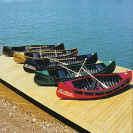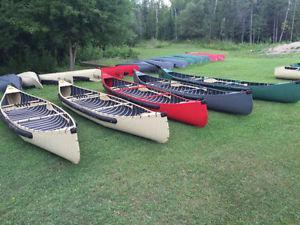The first image is the image on the left, the second image is the image on the right. For the images shown, is this caption "the image on the righ contains humans" true? Answer yes or no. No. 